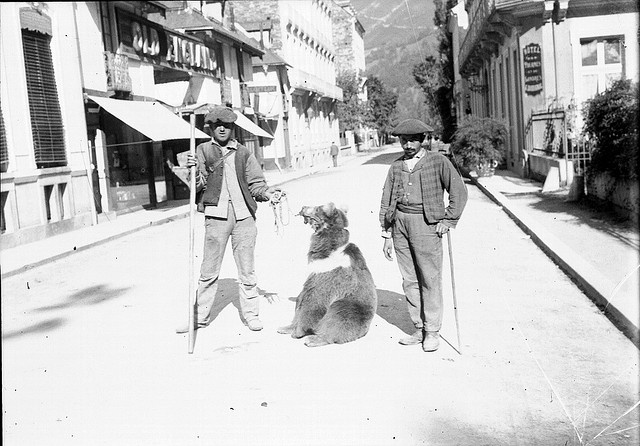Describe the objects in this image and their specific colors. I can see people in black, darkgray, lightgray, and gray tones, people in black, lightgray, darkgray, and gray tones, bear in black, darkgray, gray, and lightgray tones, and people in black, darkgray, lightgray, and dimgray tones in this image. 